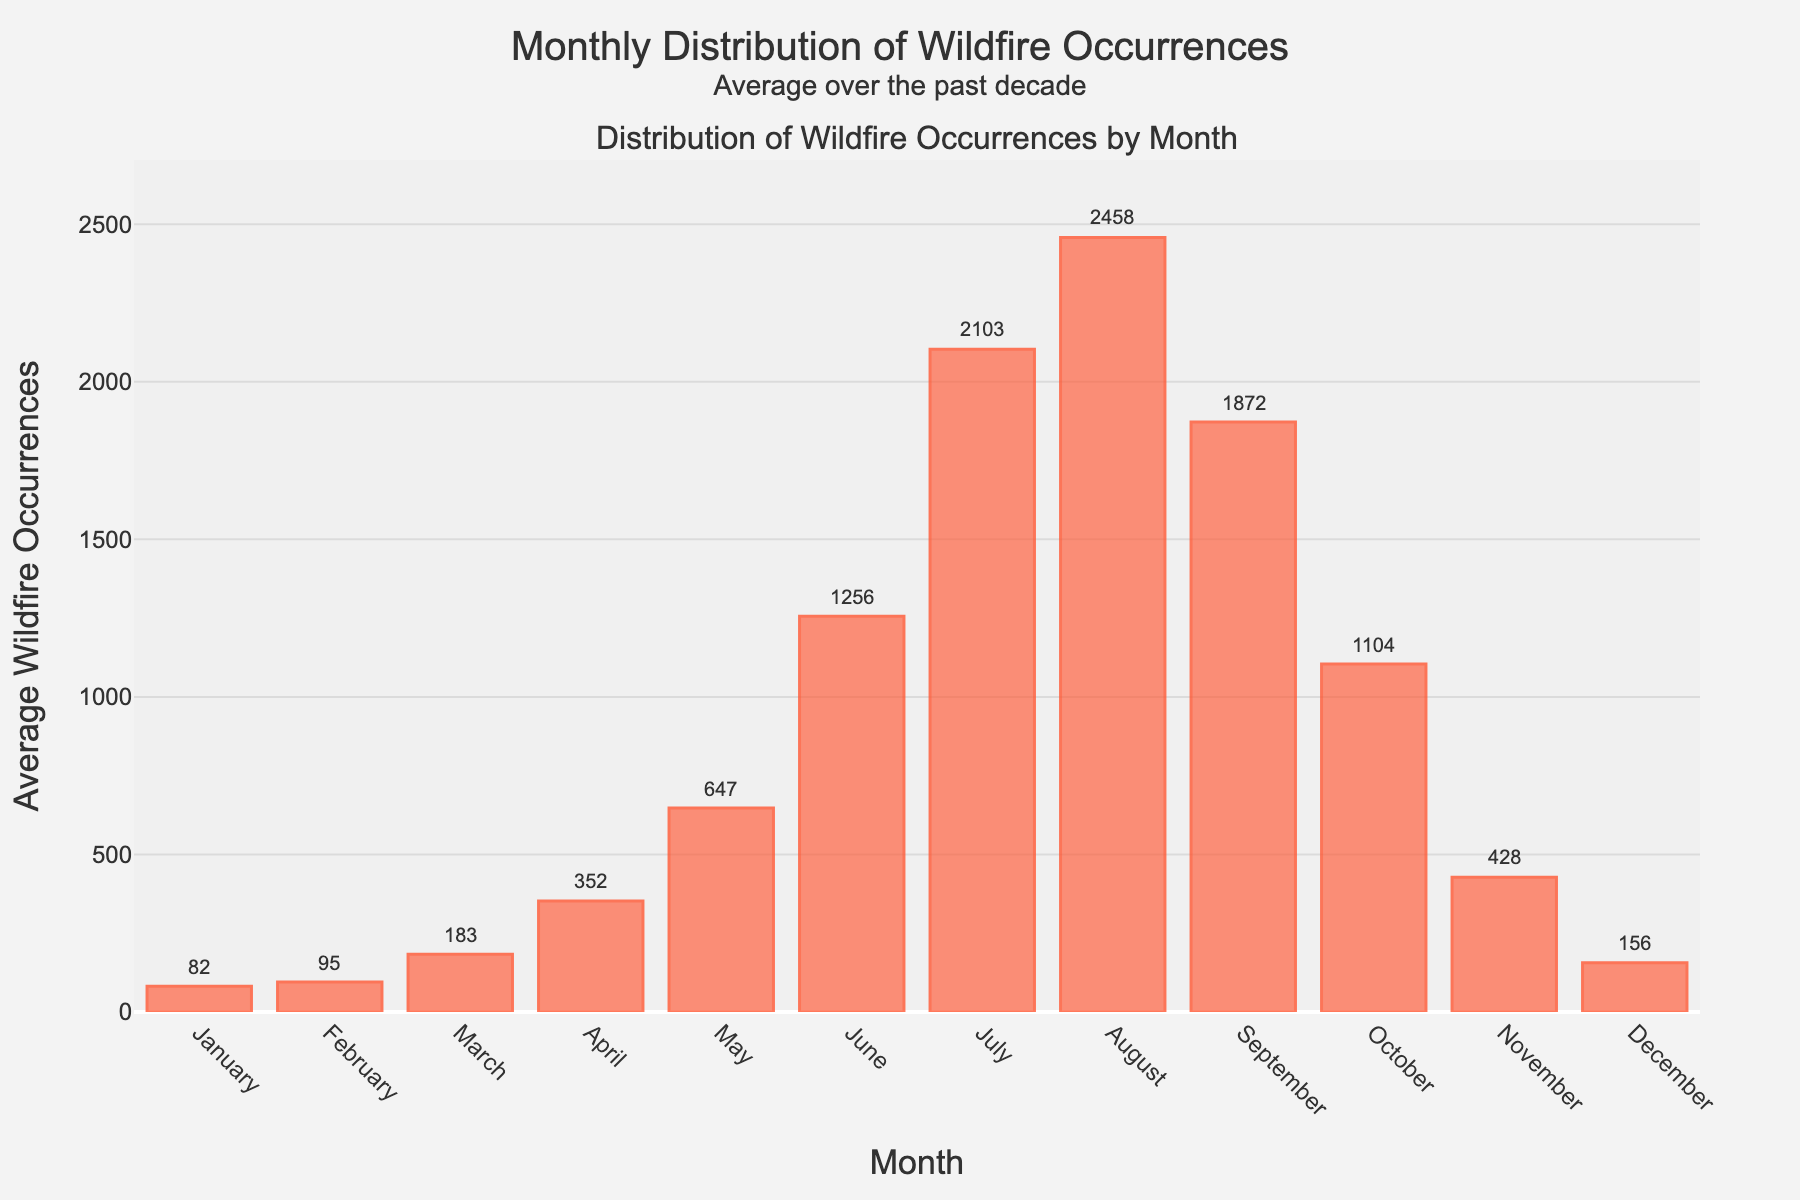Which month has the highest average wildfire occurrences? First, identify the bar that is the tallest in the plot. The month corresponding to this bar represents the highest average wildfire occurrences. August has the tallest bar.
Answer: August Which month has the lowest average wildfire occurrences? Identify the shortest bar in the plot to find which month it corresponds to. January has the shortest bar.
Answer: January How many more wildfires occur in July compared to January on average? Find the bar heights for July and January. The July bar is 2103, and the January bar is 82. Subtract the January value from the July value: 2103 - 82 = 2021.
Answer: 2021 What is the average number of wildfire occurrences in the summer months (June, July, and August)? Find the average wildfire occurrences for June, July, and August. Sum up these values: 1256 + 2103 + 2458 = 5817. Divide by the number of months, which is 3: 5817 / 3 = 1939.
Answer: 1939 Which month has an average wildfire occurrence closest to 1000? Scan the bars to find the month whose value is nearest to 1000 without exceeding it. October's value is 1104, which is closest to 1000.
Answer: October Do more wildfires typically occur in spring (March, April, May) or autumn (September, October, November)? Sum the average wildfire occurrences for the spring months: 183 + 352 + 647 = 1182. Then sum the autumn months: 1872 + 1104 + 428 = 3404. Compare the two sums: 1182 < 3404, so more wildfires occur in autumn.
Answer: Autumn By how much do the average wildfire occurrences in September exceed those in May? Find the average wildfire occurrences for September (1872) and May (647). Subtract the value for May from the value for September: 1872 - 647 = 1225.
Answer: 1225 What is the difference in average wildfire occurrences between the peak and the trough months? Identify the peak and trough months, which are August (2458) and January (82) respectively. Subtract the trough month value from the peak month value: 2458 - 82 = 2376.
Answer: 2376 